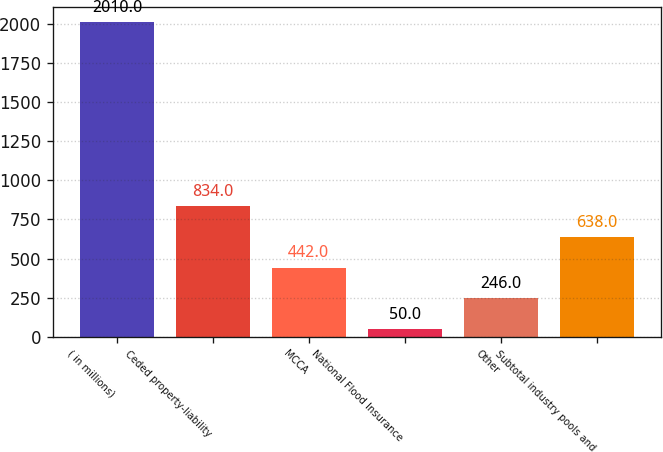Convert chart to OTSL. <chart><loc_0><loc_0><loc_500><loc_500><bar_chart><fcel>( in millions)<fcel>Ceded property-liability<fcel>MCCA<fcel>National Flood Insurance<fcel>Other<fcel>Subtotal industry pools and<nl><fcel>2010<fcel>834<fcel>442<fcel>50<fcel>246<fcel>638<nl></chart> 